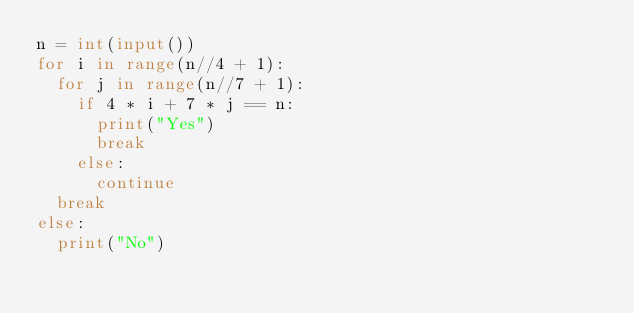<code> <loc_0><loc_0><loc_500><loc_500><_Python_>n = int(input())
for i in range(n//4 + 1):
  for j in range(n//7 + 1):
    if 4 * i + 7 * j == n:
      print("Yes")
      break
    else:
      continue
  break
else:
  print("No")</code> 